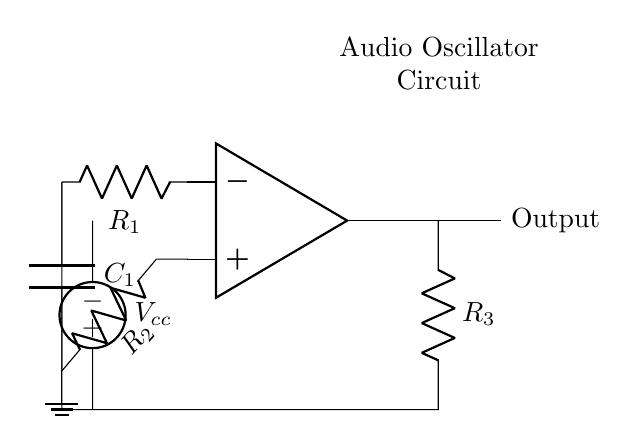What is the operational amplifier type used in this circuit? The circuit features a standard op-amp icon, commonly used in audio applications.
Answer: Operational amplifier What does the component labeled R1 represent? R1 is the resistor in the feedback loop of the op-amp, crucial for determining the gain of the oscillator circuit.
Answer: Resistor How many resistors are present in the circuit diagram? By counting the symbols in the diagram, we identify three resistors present, namely R1, R2, and R3.
Answer: Three What is the role of the capacitor C1 in this circuit? C1, connected at the inverting input, introduces the necessary phase shifting for oscillation, making it essential for frequency generation.
Answer: Phase shifting What is the function of the voltage source in the circuit? The voltage source provides the necessary power for the circuit to operate, enabling it to generate audio frequencies through the amplifier configuration.
Answer: Power supply Explain how the circuit achieves frequency oscillation. The circuit forms a feedback loop with the resistors and capacitor, where R3 and C1 determine the frequency of oscillation. The feedback from the output to the input inverts the signal, creating a continuous oscillation with a specific frequency defined by these components.
Answer: Feedback loop and component values 